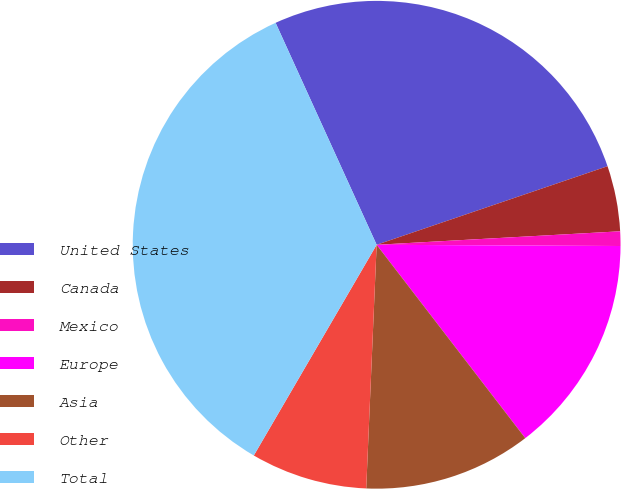Convert chart. <chart><loc_0><loc_0><loc_500><loc_500><pie_chart><fcel>United States<fcel>Canada<fcel>Mexico<fcel>Europe<fcel>Asia<fcel>Other<fcel>Total<nl><fcel>26.58%<fcel>4.34%<fcel>0.96%<fcel>14.49%<fcel>11.11%<fcel>7.72%<fcel>34.8%<nl></chart> 